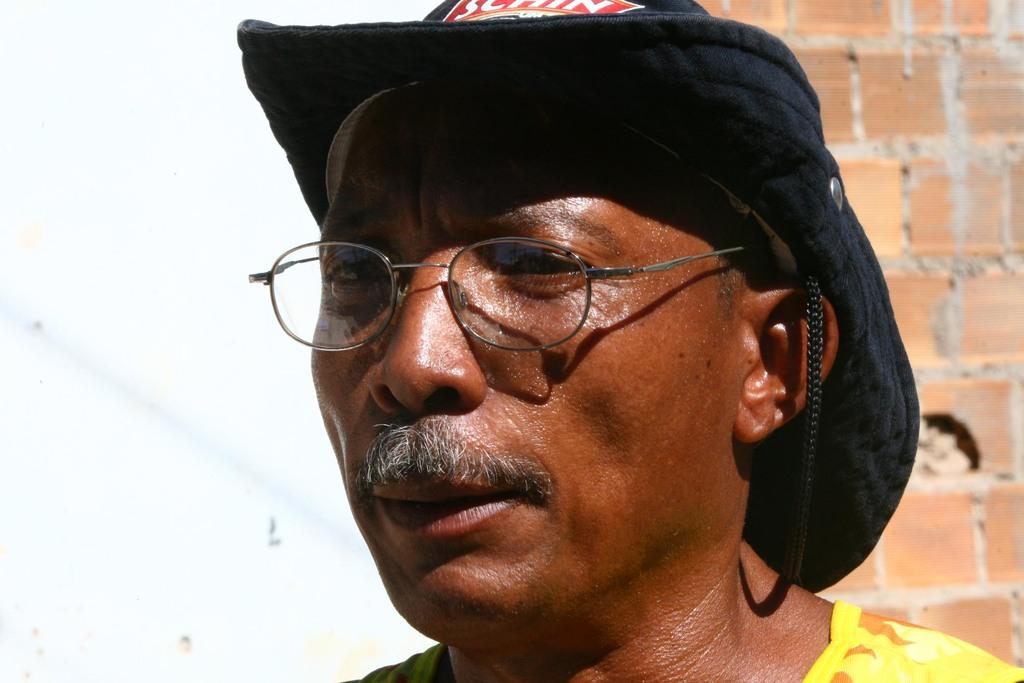Who or what is present in the image? There is a person in the image. What is the person wearing on their head? The person is wearing a hat. What type of background can be seen in the image? There is a brick wall visible in the image. What type of ornament is hanging from the person's hat in the image? There is no ornament hanging from the person's hat in the image. 